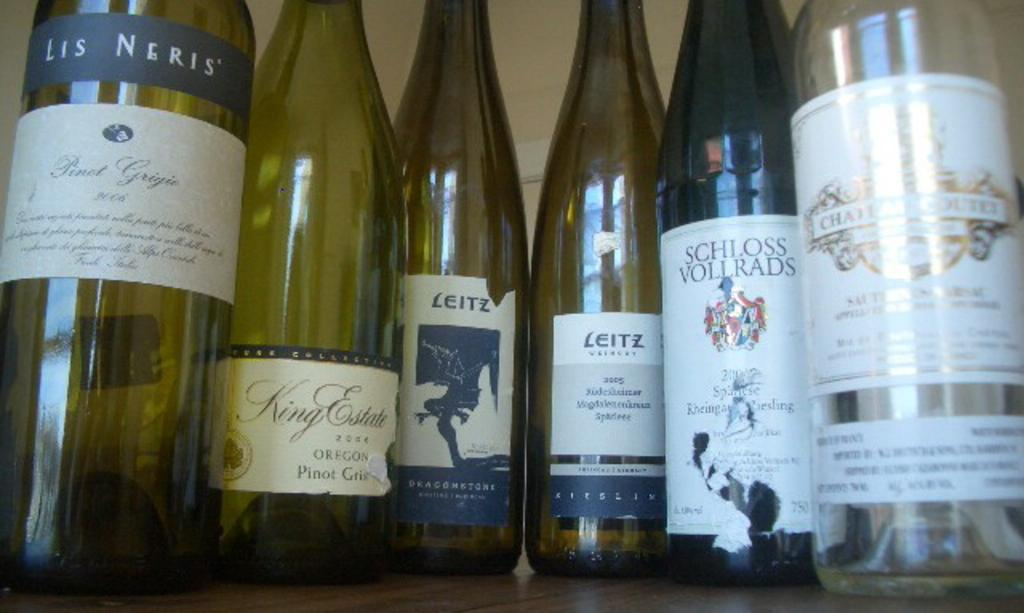What objects can be seen in the image? There are bottles in the image. What is unique about each bottle? Each bottle has a sticker on it. What type of soup is being served in the vessel in the image? There is no vessel or soup present in the image; it only features bottles with stickers on them. 